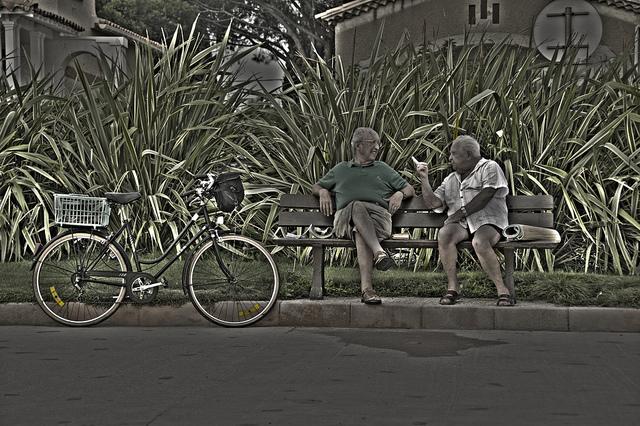What is the pattern type on the bench called?
Give a very brief answer. Solid. Does this photo seem kind of gross?
Keep it brief. No. How many women in this picture?
Give a very brief answer. 0. What is in the basket on the bicycle?
Be succinct. Nothing. What animal is on the bench?
Write a very short answer. Human. Where does it look like this bikes are parked?
Quick response, please. Street. What is the name of the metal item in the front-left of the picture?
Concise answer only. Bicycle. Is this couple married?
Quick response, please. No. Are the man standing up?
Concise answer only. No. Why are the people dressed like that?
Answer briefly. Summer. 